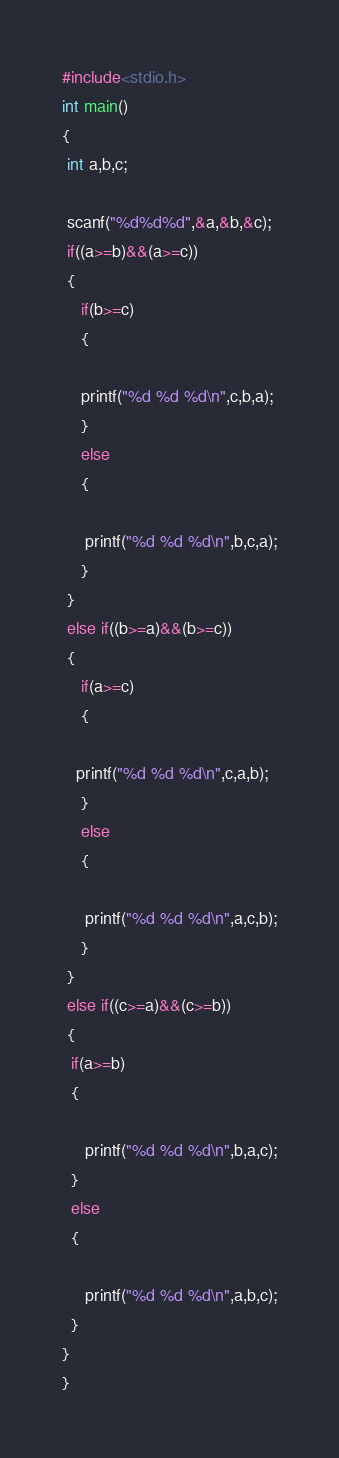Convert code to text. <code><loc_0><loc_0><loc_500><loc_500><_C_>#include<stdio.h>
int main()
{
 int a,b,c;

 scanf("%d%d%d",&a,&b,&c);
 if((a>=b)&&(a>=c))
 {
    if(b>=c)
    {

    printf("%d %d %d\n",c,b,a);
    }
    else
    {

     printf("%d %d %d\n",b,c,a);
    }
 }
 else if((b>=a)&&(b>=c))
 {
    if(a>=c)
    {

   printf("%d %d %d\n",c,a,b);
    }
    else
    {

     printf("%d %d %d\n",a,c,b);
    }
 }
 else if((c>=a)&&(c>=b))
 {
  if(a>=b)
  {

     printf("%d %d %d\n",b,a,c);
  }
  else
  {

     printf("%d %d %d\n",a,b,c);
  }
}
}
</code> 